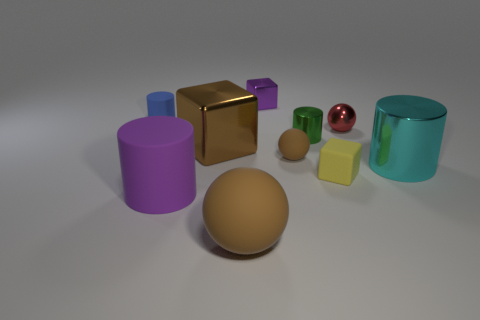What is the material of the cylinder that is the same color as the small metal block?
Offer a terse response. Rubber. Do the cyan cylinder and the metal ball have the same size?
Your answer should be very brief. No. Is the number of yellow metallic balls greater than the number of small shiny things?
Give a very brief answer. No. How many other things are there of the same color as the shiny ball?
Your response must be concise. 0. What number of objects are big purple matte cylinders or tiny yellow cubes?
Your answer should be compact. 2. There is a rubber object on the left side of the large purple rubber cylinder; does it have the same shape as the brown shiny thing?
Your answer should be compact. No. There is a small block that is in front of the big cylinder that is right of the purple rubber object; what color is it?
Your response must be concise. Yellow. Are there fewer blocks than cyan matte balls?
Offer a terse response. No. Is there a tiny gray thing that has the same material as the purple cylinder?
Offer a terse response. No. There is a tiny brown object; is it the same shape as the brown matte object that is on the left side of the small purple thing?
Make the answer very short. Yes. 